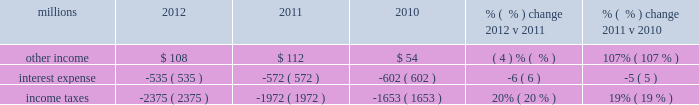Maintenance and contract expenses incurred by our subsidiaries for external transportation services ) ; materials used to maintain the railroad 2019s lines , structures , and equipment ; costs of operating facilities jointly used by uprr and other railroads ; transportation and lodging for train crew employees ; trucking and contracting costs for intermodal containers ; leased automobile maintenance expenses ; and tools and supplies .
Expenses for contract services increased $ 103 million in 2012 versus 2011 , primarily due to increased demand for transportation services purchased by our logistics subsidiaries for their customers and additional costs for repair and maintenance of locomotives and freight cars .
Expenses for contract services increased $ 106 million in 2011 versus 2010 , driven by volume-related external transportation services incurred by our subsidiaries , and various other types of contractual services , including flood-related repairs , mitigation and improvements .
Volume-related crew transportation and lodging costs , as well as expenses associated with jointly owned operating facilities , also increased costs compared to 2010 .
In addition , an increase in locomotive maintenance materials used to prepare a portion of our locomotive fleet for return to active service due to increased volume and additional capacity for weather related issues and warranty expirations increased expenses in 2011 .
Depreciation 2013 the majority of depreciation relates to road property , including rail , ties , ballast , and other track material .
A higher depreciable asset base , reflecting ongoing capital spending , increased depreciation expense in 2012 compared to 2011 .
A higher depreciable asset base , reflecting ongoing capital spending , increased depreciation expense in 2011 compared to 2010 .
Higher depreciation rates for rail and other track material also contributed to the increase .
The higher rates , which became effective january 1 , 2011 , resulted primarily from increased track usage ( based on higher gross ton-miles in 2010 ) .
Equipment and other rents 2013 equipment and other rents expense primarily includes rental expense that the railroad pays for freight cars owned by other railroads or private companies ; freight car , intermodal , and locomotive leases ; and office and other rent expenses .
Increased automotive and intermodal shipments , partially offset by improved car-cycle times , drove an increase in our short-term freight car rental expense in 2012 .
Conversely , lower locomotive lease expense partially offset the higher freight car rental expense .
Costs increased in 2011 versus 2010 as higher short-term freight car rental expense and container lease expense offset lower freight car and locomotive lease expense .
Other 2013 other expenses include personal injury , freight and property damage , destruction of equipment , insurance , environmental , bad debt , state and local taxes , utilities , telephone and cellular , employee travel , computer software , and other general expenses .
Other costs in 2012 were slightly higher than 2011 primarily due to higher property taxes .
Despite continual improvement in our safety experience and lower estimated annual costs , personal injury expense increased in 2012 compared to 2011 , as the liability reduction resulting from historical claim experience was less than the reduction in 2011 .
Higher property taxes , casualty costs associated with destroyed equipment , damaged freight and property and environmental costs increased other costs in 2011 compared to 2010 .
A one-time payment of $ 45 million in the first quarter of 2010 related to a transaction with csxi and continued improvement in our safety performance and lower estimated liability for personal injury , which reduced our personal injury expense year-over-year , partially offset increases in other costs .
Non-operating items millions 2012 2011 2010 % (  % ) change 2012 v 2011 % (  % ) change 2011 v 2010 .
Other income 2013 other income decreased in 2012 versus 2011 due to lower gains from real estate sales and higher environmental costs associated with non-operating properties , partially offset by an interest payment from a tax refund. .
Was 2010 interest expense greater than the nonrecurring expenses of the one-time payment to csx in the first quarter of 2010? 
Computations: (602 > 45)
Answer: yes. 